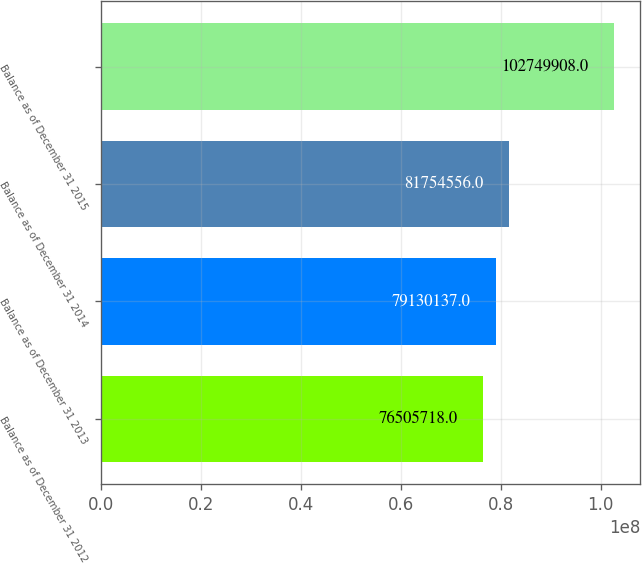Convert chart. <chart><loc_0><loc_0><loc_500><loc_500><bar_chart><fcel>Balance as of December 31 2012<fcel>Balance as of December 31 2013<fcel>Balance as of December 31 2014<fcel>Balance as of December 31 2015<nl><fcel>7.65057e+07<fcel>7.91301e+07<fcel>8.17546e+07<fcel>1.0275e+08<nl></chart> 